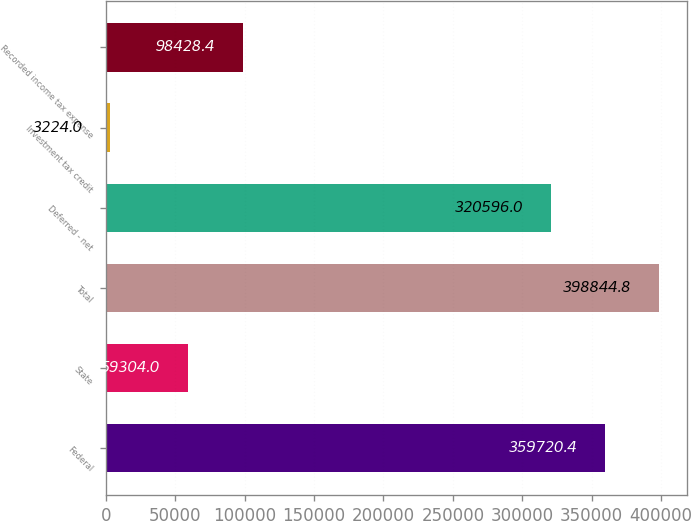<chart> <loc_0><loc_0><loc_500><loc_500><bar_chart><fcel>Federal<fcel>State<fcel>Total<fcel>Deferred - net<fcel>Investment tax credit<fcel>Recorded income tax expense<nl><fcel>359720<fcel>59304<fcel>398845<fcel>320596<fcel>3224<fcel>98428.4<nl></chart> 